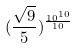Convert formula to latex. <formula><loc_0><loc_0><loc_500><loc_500>( \frac { \sqrt { 9 } } { 5 } ) ^ { \frac { 1 0 ^ { 1 0 } } { 1 0 } }</formula> 